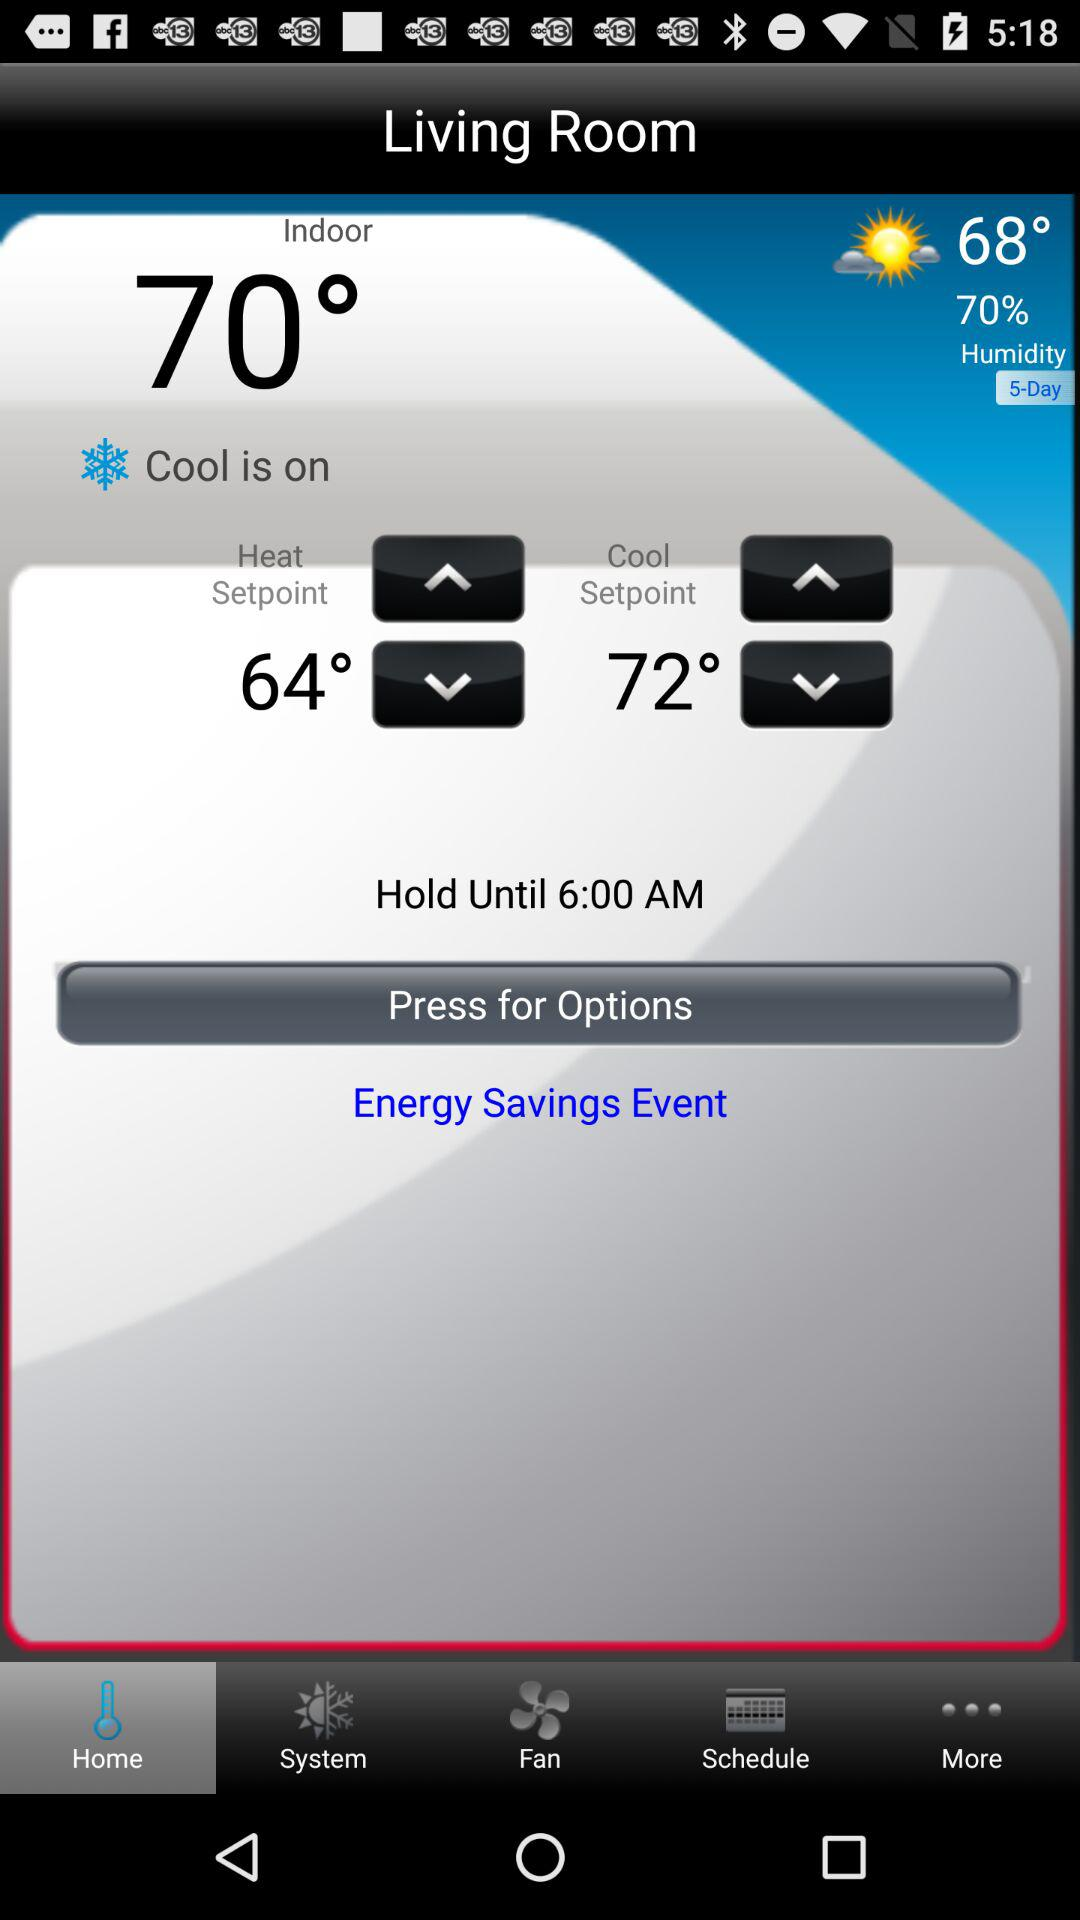What is "on" currently? Currently, cool is "on". 